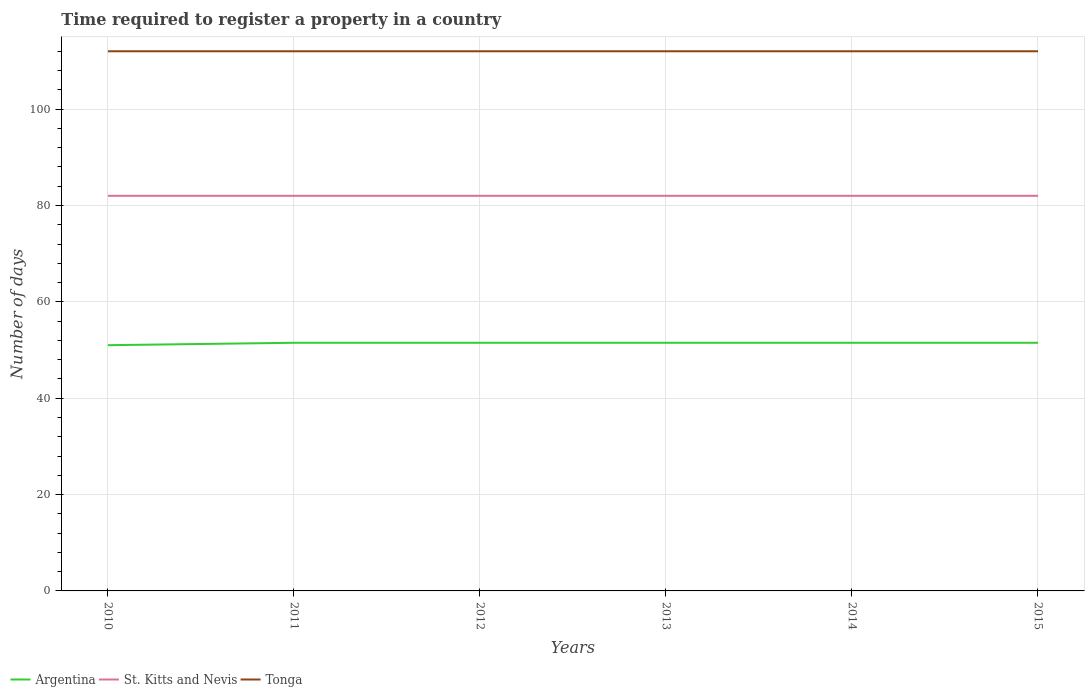How many different coloured lines are there?
Ensure brevity in your answer.  3. Does the line corresponding to Argentina intersect with the line corresponding to St. Kitts and Nevis?
Offer a terse response. No. Across all years, what is the maximum number of days required to register a property in St. Kitts and Nevis?
Make the answer very short. 82. In which year was the number of days required to register a property in Argentina maximum?
Your answer should be very brief. 2010. Is the number of days required to register a property in St. Kitts and Nevis strictly greater than the number of days required to register a property in Tonga over the years?
Offer a terse response. Yes. How many lines are there?
Make the answer very short. 3. How many years are there in the graph?
Make the answer very short. 6. What is the difference between two consecutive major ticks on the Y-axis?
Your answer should be compact. 20. Are the values on the major ticks of Y-axis written in scientific E-notation?
Your answer should be compact. No. Does the graph contain grids?
Your answer should be compact. Yes. How are the legend labels stacked?
Your answer should be very brief. Horizontal. What is the title of the graph?
Make the answer very short. Time required to register a property in a country. Does "Russian Federation" appear as one of the legend labels in the graph?
Ensure brevity in your answer.  No. What is the label or title of the Y-axis?
Ensure brevity in your answer.  Number of days. What is the Number of days of Argentina in 2010?
Offer a terse response. 51. What is the Number of days in St. Kitts and Nevis in 2010?
Offer a terse response. 82. What is the Number of days in Tonga in 2010?
Keep it short and to the point. 112. What is the Number of days in Argentina in 2011?
Make the answer very short. 51.5. What is the Number of days of Tonga in 2011?
Make the answer very short. 112. What is the Number of days in Argentina in 2012?
Keep it short and to the point. 51.5. What is the Number of days of Tonga in 2012?
Provide a succinct answer. 112. What is the Number of days in Argentina in 2013?
Provide a short and direct response. 51.5. What is the Number of days in Tonga in 2013?
Provide a short and direct response. 112. What is the Number of days of Argentina in 2014?
Offer a terse response. 51.5. What is the Number of days in St. Kitts and Nevis in 2014?
Keep it short and to the point. 82. What is the Number of days of Tonga in 2014?
Keep it short and to the point. 112. What is the Number of days in Argentina in 2015?
Ensure brevity in your answer.  51.5. What is the Number of days in St. Kitts and Nevis in 2015?
Give a very brief answer. 82. What is the Number of days in Tonga in 2015?
Your response must be concise. 112. Across all years, what is the maximum Number of days in Argentina?
Ensure brevity in your answer.  51.5. Across all years, what is the maximum Number of days in St. Kitts and Nevis?
Your answer should be compact. 82. Across all years, what is the maximum Number of days of Tonga?
Your answer should be very brief. 112. Across all years, what is the minimum Number of days of Argentina?
Your answer should be compact. 51. Across all years, what is the minimum Number of days in Tonga?
Keep it short and to the point. 112. What is the total Number of days of Argentina in the graph?
Give a very brief answer. 308.5. What is the total Number of days of St. Kitts and Nevis in the graph?
Ensure brevity in your answer.  492. What is the total Number of days of Tonga in the graph?
Keep it short and to the point. 672. What is the difference between the Number of days in Argentina in 2010 and that in 2011?
Make the answer very short. -0.5. What is the difference between the Number of days of Tonga in 2010 and that in 2011?
Your response must be concise. 0. What is the difference between the Number of days of Tonga in 2010 and that in 2012?
Your response must be concise. 0. What is the difference between the Number of days in Argentina in 2010 and that in 2013?
Provide a succinct answer. -0.5. What is the difference between the Number of days in Tonga in 2010 and that in 2014?
Keep it short and to the point. 0. What is the difference between the Number of days in Argentina in 2011 and that in 2012?
Keep it short and to the point. 0. What is the difference between the Number of days in Argentina in 2011 and that in 2013?
Offer a terse response. 0. What is the difference between the Number of days in St. Kitts and Nevis in 2011 and that in 2013?
Your answer should be compact. 0. What is the difference between the Number of days of Tonga in 2011 and that in 2013?
Keep it short and to the point. 0. What is the difference between the Number of days in Argentina in 2012 and that in 2013?
Keep it short and to the point. 0. What is the difference between the Number of days in St. Kitts and Nevis in 2012 and that in 2013?
Provide a short and direct response. 0. What is the difference between the Number of days in Tonga in 2012 and that in 2013?
Offer a very short reply. 0. What is the difference between the Number of days in St. Kitts and Nevis in 2012 and that in 2014?
Offer a very short reply. 0. What is the difference between the Number of days in Tonga in 2012 and that in 2014?
Offer a very short reply. 0. What is the difference between the Number of days in St. Kitts and Nevis in 2012 and that in 2015?
Offer a very short reply. 0. What is the difference between the Number of days in Tonga in 2012 and that in 2015?
Keep it short and to the point. 0. What is the difference between the Number of days of Argentina in 2013 and that in 2014?
Offer a very short reply. 0. What is the difference between the Number of days in Tonga in 2013 and that in 2014?
Your answer should be very brief. 0. What is the difference between the Number of days of St. Kitts and Nevis in 2013 and that in 2015?
Your answer should be compact. 0. What is the difference between the Number of days of Tonga in 2013 and that in 2015?
Make the answer very short. 0. What is the difference between the Number of days of Argentina in 2014 and that in 2015?
Offer a very short reply. 0. What is the difference between the Number of days of Argentina in 2010 and the Number of days of St. Kitts and Nevis in 2011?
Your answer should be very brief. -31. What is the difference between the Number of days in Argentina in 2010 and the Number of days in Tonga in 2011?
Keep it short and to the point. -61. What is the difference between the Number of days of St. Kitts and Nevis in 2010 and the Number of days of Tonga in 2011?
Offer a very short reply. -30. What is the difference between the Number of days of Argentina in 2010 and the Number of days of St. Kitts and Nevis in 2012?
Your answer should be very brief. -31. What is the difference between the Number of days of Argentina in 2010 and the Number of days of Tonga in 2012?
Provide a short and direct response. -61. What is the difference between the Number of days of St. Kitts and Nevis in 2010 and the Number of days of Tonga in 2012?
Provide a succinct answer. -30. What is the difference between the Number of days of Argentina in 2010 and the Number of days of St. Kitts and Nevis in 2013?
Offer a terse response. -31. What is the difference between the Number of days in Argentina in 2010 and the Number of days in Tonga in 2013?
Give a very brief answer. -61. What is the difference between the Number of days of St. Kitts and Nevis in 2010 and the Number of days of Tonga in 2013?
Your answer should be compact. -30. What is the difference between the Number of days in Argentina in 2010 and the Number of days in St. Kitts and Nevis in 2014?
Your answer should be very brief. -31. What is the difference between the Number of days in Argentina in 2010 and the Number of days in Tonga in 2014?
Offer a terse response. -61. What is the difference between the Number of days of Argentina in 2010 and the Number of days of St. Kitts and Nevis in 2015?
Ensure brevity in your answer.  -31. What is the difference between the Number of days in Argentina in 2010 and the Number of days in Tonga in 2015?
Your answer should be very brief. -61. What is the difference between the Number of days in Argentina in 2011 and the Number of days in St. Kitts and Nevis in 2012?
Your answer should be compact. -30.5. What is the difference between the Number of days in Argentina in 2011 and the Number of days in Tonga in 2012?
Provide a succinct answer. -60.5. What is the difference between the Number of days in Argentina in 2011 and the Number of days in St. Kitts and Nevis in 2013?
Offer a very short reply. -30.5. What is the difference between the Number of days in Argentina in 2011 and the Number of days in Tonga in 2013?
Offer a terse response. -60.5. What is the difference between the Number of days of St. Kitts and Nevis in 2011 and the Number of days of Tonga in 2013?
Keep it short and to the point. -30. What is the difference between the Number of days of Argentina in 2011 and the Number of days of St. Kitts and Nevis in 2014?
Keep it short and to the point. -30.5. What is the difference between the Number of days of Argentina in 2011 and the Number of days of Tonga in 2014?
Make the answer very short. -60.5. What is the difference between the Number of days of St. Kitts and Nevis in 2011 and the Number of days of Tonga in 2014?
Your response must be concise. -30. What is the difference between the Number of days of Argentina in 2011 and the Number of days of St. Kitts and Nevis in 2015?
Provide a short and direct response. -30.5. What is the difference between the Number of days in Argentina in 2011 and the Number of days in Tonga in 2015?
Offer a very short reply. -60.5. What is the difference between the Number of days of St. Kitts and Nevis in 2011 and the Number of days of Tonga in 2015?
Ensure brevity in your answer.  -30. What is the difference between the Number of days in Argentina in 2012 and the Number of days in St. Kitts and Nevis in 2013?
Your response must be concise. -30.5. What is the difference between the Number of days of Argentina in 2012 and the Number of days of Tonga in 2013?
Your response must be concise. -60.5. What is the difference between the Number of days of Argentina in 2012 and the Number of days of St. Kitts and Nevis in 2014?
Provide a short and direct response. -30.5. What is the difference between the Number of days in Argentina in 2012 and the Number of days in Tonga in 2014?
Give a very brief answer. -60.5. What is the difference between the Number of days in Argentina in 2012 and the Number of days in St. Kitts and Nevis in 2015?
Provide a short and direct response. -30.5. What is the difference between the Number of days of Argentina in 2012 and the Number of days of Tonga in 2015?
Offer a very short reply. -60.5. What is the difference between the Number of days of Argentina in 2013 and the Number of days of St. Kitts and Nevis in 2014?
Ensure brevity in your answer.  -30.5. What is the difference between the Number of days of Argentina in 2013 and the Number of days of Tonga in 2014?
Make the answer very short. -60.5. What is the difference between the Number of days of Argentina in 2013 and the Number of days of St. Kitts and Nevis in 2015?
Your response must be concise. -30.5. What is the difference between the Number of days in Argentina in 2013 and the Number of days in Tonga in 2015?
Your answer should be compact. -60.5. What is the difference between the Number of days in St. Kitts and Nevis in 2013 and the Number of days in Tonga in 2015?
Ensure brevity in your answer.  -30. What is the difference between the Number of days of Argentina in 2014 and the Number of days of St. Kitts and Nevis in 2015?
Offer a terse response. -30.5. What is the difference between the Number of days of Argentina in 2014 and the Number of days of Tonga in 2015?
Provide a succinct answer. -60.5. What is the difference between the Number of days in St. Kitts and Nevis in 2014 and the Number of days in Tonga in 2015?
Keep it short and to the point. -30. What is the average Number of days in Argentina per year?
Ensure brevity in your answer.  51.42. What is the average Number of days of Tonga per year?
Offer a terse response. 112. In the year 2010, what is the difference between the Number of days of Argentina and Number of days of St. Kitts and Nevis?
Your answer should be very brief. -31. In the year 2010, what is the difference between the Number of days of Argentina and Number of days of Tonga?
Your response must be concise. -61. In the year 2011, what is the difference between the Number of days in Argentina and Number of days in St. Kitts and Nevis?
Offer a very short reply. -30.5. In the year 2011, what is the difference between the Number of days of Argentina and Number of days of Tonga?
Provide a succinct answer. -60.5. In the year 2011, what is the difference between the Number of days of St. Kitts and Nevis and Number of days of Tonga?
Your answer should be very brief. -30. In the year 2012, what is the difference between the Number of days in Argentina and Number of days in St. Kitts and Nevis?
Your answer should be very brief. -30.5. In the year 2012, what is the difference between the Number of days of Argentina and Number of days of Tonga?
Your answer should be compact. -60.5. In the year 2012, what is the difference between the Number of days of St. Kitts and Nevis and Number of days of Tonga?
Your answer should be compact. -30. In the year 2013, what is the difference between the Number of days of Argentina and Number of days of St. Kitts and Nevis?
Provide a succinct answer. -30.5. In the year 2013, what is the difference between the Number of days in Argentina and Number of days in Tonga?
Offer a very short reply. -60.5. In the year 2013, what is the difference between the Number of days in St. Kitts and Nevis and Number of days in Tonga?
Your answer should be compact. -30. In the year 2014, what is the difference between the Number of days in Argentina and Number of days in St. Kitts and Nevis?
Your answer should be very brief. -30.5. In the year 2014, what is the difference between the Number of days of Argentina and Number of days of Tonga?
Keep it short and to the point. -60.5. In the year 2015, what is the difference between the Number of days of Argentina and Number of days of St. Kitts and Nevis?
Provide a short and direct response. -30.5. In the year 2015, what is the difference between the Number of days in Argentina and Number of days in Tonga?
Provide a short and direct response. -60.5. In the year 2015, what is the difference between the Number of days of St. Kitts and Nevis and Number of days of Tonga?
Your answer should be compact. -30. What is the ratio of the Number of days of Argentina in 2010 to that in 2011?
Provide a short and direct response. 0.99. What is the ratio of the Number of days in Tonga in 2010 to that in 2011?
Offer a very short reply. 1. What is the ratio of the Number of days of Argentina in 2010 to that in 2012?
Give a very brief answer. 0.99. What is the ratio of the Number of days of St. Kitts and Nevis in 2010 to that in 2012?
Keep it short and to the point. 1. What is the ratio of the Number of days in Argentina in 2010 to that in 2013?
Provide a succinct answer. 0.99. What is the ratio of the Number of days of Tonga in 2010 to that in 2013?
Your response must be concise. 1. What is the ratio of the Number of days of Argentina in 2010 to that in 2014?
Give a very brief answer. 0.99. What is the ratio of the Number of days of St. Kitts and Nevis in 2010 to that in 2014?
Make the answer very short. 1. What is the ratio of the Number of days of Tonga in 2010 to that in 2014?
Keep it short and to the point. 1. What is the ratio of the Number of days of Argentina in 2010 to that in 2015?
Offer a very short reply. 0.99. What is the ratio of the Number of days in Argentina in 2011 to that in 2012?
Provide a short and direct response. 1. What is the ratio of the Number of days of St. Kitts and Nevis in 2011 to that in 2012?
Ensure brevity in your answer.  1. What is the ratio of the Number of days in Argentina in 2011 to that in 2013?
Provide a short and direct response. 1. What is the ratio of the Number of days in St. Kitts and Nevis in 2011 to that in 2013?
Offer a terse response. 1. What is the ratio of the Number of days of Tonga in 2011 to that in 2013?
Make the answer very short. 1. What is the ratio of the Number of days in Tonga in 2011 to that in 2014?
Keep it short and to the point. 1. What is the ratio of the Number of days of Argentina in 2011 to that in 2015?
Ensure brevity in your answer.  1. What is the ratio of the Number of days of Tonga in 2011 to that in 2015?
Provide a short and direct response. 1. What is the ratio of the Number of days in St. Kitts and Nevis in 2012 to that in 2013?
Provide a short and direct response. 1. What is the ratio of the Number of days in Tonga in 2012 to that in 2014?
Ensure brevity in your answer.  1. What is the ratio of the Number of days of Argentina in 2012 to that in 2015?
Provide a succinct answer. 1. What is the ratio of the Number of days of St. Kitts and Nevis in 2012 to that in 2015?
Offer a terse response. 1. What is the ratio of the Number of days of St. Kitts and Nevis in 2013 to that in 2014?
Keep it short and to the point. 1. What is the ratio of the Number of days of Argentina in 2013 to that in 2015?
Your response must be concise. 1. What is the ratio of the Number of days of St. Kitts and Nevis in 2013 to that in 2015?
Keep it short and to the point. 1. What is the ratio of the Number of days in Argentina in 2014 to that in 2015?
Give a very brief answer. 1. What is the ratio of the Number of days in St. Kitts and Nevis in 2014 to that in 2015?
Your answer should be very brief. 1. What is the ratio of the Number of days in Tonga in 2014 to that in 2015?
Your response must be concise. 1. What is the difference between the highest and the second highest Number of days in Argentina?
Provide a succinct answer. 0. What is the difference between the highest and the second highest Number of days in St. Kitts and Nevis?
Provide a short and direct response. 0. What is the difference between the highest and the second highest Number of days in Tonga?
Offer a very short reply. 0. What is the difference between the highest and the lowest Number of days of Tonga?
Offer a terse response. 0. 